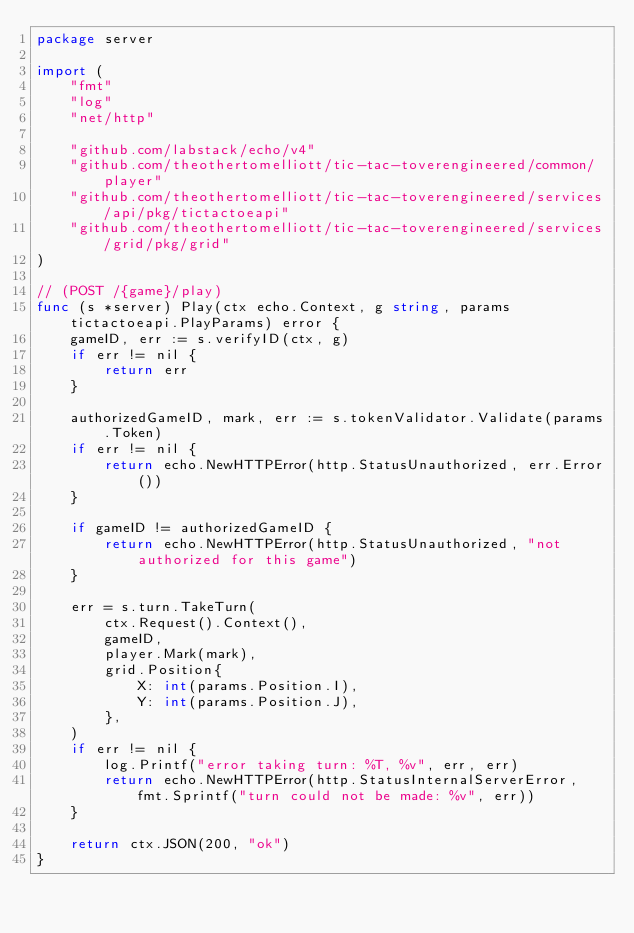<code> <loc_0><loc_0><loc_500><loc_500><_Go_>package server

import (
	"fmt"
	"log"
	"net/http"

	"github.com/labstack/echo/v4"
	"github.com/theothertomelliott/tic-tac-toverengineered/common/player"
	"github.com/theothertomelliott/tic-tac-toverengineered/services/api/pkg/tictactoeapi"
	"github.com/theothertomelliott/tic-tac-toverengineered/services/grid/pkg/grid"
)

// (POST /{game}/play)
func (s *server) Play(ctx echo.Context, g string, params tictactoeapi.PlayParams) error {
	gameID, err := s.verifyID(ctx, g)
	if err != nil {
		return err
	}

	authorizedGameID, mark, err := s.tokenValidator.Validate(params.Token)
	if err != nil {
		return echo.NewHTTPError(http.StatusUnauthorized, err.Error())
	}

	if gameID != authorizedGameID {
		return echo.NewHTTPError(http.StatusUnauthorized, "not authorized for this game")
	}

	err = s.turn.TakeTurn(
		ctx.Request().Context(),
		gameID,
		player.Mark(mark),
		grid.Position{
			X: int(params.Position.I),
			Y: int(params.Position.J),
		},
	)
	if err != nil {
		log.Printf("error taking turn: %T, %v", err, err)
		return echo.NewHTTPError(http.StatusInternalServerError, fmt.Sprintf("turn could not be made: %v", err))
	}

	return ctx.JSON(200, "ok")
}
</code> 